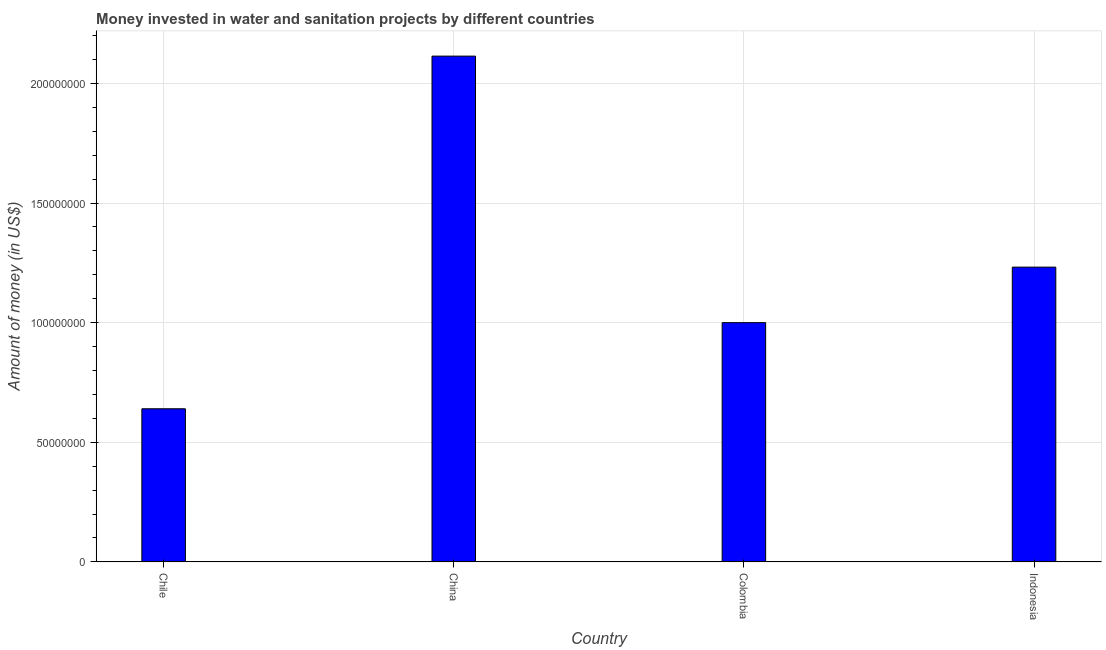What is the title of the graph?
Provide a short and direct response. Money invested in water and sanitation projects by different countries. What is the label or title of the X-axis?
Offer a terse response. Country. What is the label or title of the Y-axis?
Make the answer very short. Amount of money (in US$). What is the investment in Chile?
Your answer should be very brief. 6.40e+07. Across all countries, what is the maximum investment?
Offer a terse response. 2.11e+08. Across all countries, what is the minimum investment?
Provide a succinct answer. 6.40e+07. In which country was the investment minimum?
Your answer should be compact. Chile. What is the sum of the investment?
Provide a short and direct response. 4.99e+08. What is the difference between the investment in Colombia and Indonesia?
Offer a terse response. -2.32e+07. What is the average investment per country?
Offer a terse response. 1.25e+08. What is the median investment?
Keep it short and to the point. 1.12e+08. What is the ratio of the investment in Chile to that in Colombia?
Offer a terse response. 0.64. Is the investment in Chile less than that in Colombia?
Your answer should be compact. Yes. Is the difference between the investment in Colombia and Indonesia greater than the difference between any two countries?
Your answer should be very brief. No. What is the difference between the highest and the second highest investment?
Provide a succinct answer. 8.82e+07. Is the sum of the investment in Colombia and Indonesia greater than the maximum investment across all countries?
Your answer should be very brief. Yes. What is the difference between the highest and the lowest investment?
Keep it short and to the point. 1.47e+08. How many bars are there?
Your answer should be very brief. 4. Are all the bars in the graph horizontal?
Provide a succinct answer. No. How many countries are there in the graph?
Ensure brevity in your answer.  4. Are the values on the major ticks of Y-axis written in scientific E-notation?
Your response must be concise. No. What is the Amount of money (in US$) of Chile?
Provide a succinct answer. 6.40e+07. What is the Amount of money (in US$) in China?
Give a very brief answer. 2.11e+08. What is the Amount of money (in US$) in Indonesia?
Your answer should be very brief. 1.23e+08. What is the difference between the Amount of money (in US$) in Chile and China?
Your answer should be compact. -1.47e+08. What is the difference between the Amount of money (in US$) in Chile and Colombia?
Offer a very short reply. -3.60e+07. What is the difference between the Amount of money (in US$) in Chile and Indonesia?
Provide a short and direct response. -5.92e+07. What is the difference between the Amount of money (in US$) in China and Colombia?
Your response must be concise. 1.11e+08. What is the difference between the Amount of money (in US$) in China and Indonesia?
Make the answer very short. 8.82e+07. What is the difference between the Amount of money (in US$) in Colombia and Indonesia?
Give a very brief answer. -2.32e+07. What is the ratio of the Amount of money (in US$) in Chile to that in China?
Offer a terse response. 0.3. What is the ratio of the Amount of money (in US$) in Chile to that in Colombia?
Provide a short and direct response. 0.64. What is the ratio of the Amount of money (in US$) in Chile to that in Indonesia?
Provide a short and direct response. 0.52. What is the ratio of the Amount of money (in US$) in China to that in Colombia?
Provide a short and direct response. 2.11. What is the ratio of the Amount of money (in US$) in China to that in Indonesia?
Ensure brevity in your answer.  1.72. What is the ratio of the Amount of money (in US$) in Colombia to that in Indonesia?
Your answer should be very brief. 0.81. 